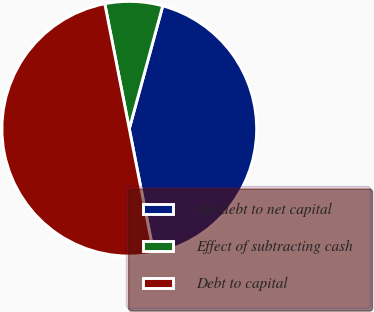Convert chart. <chart><loc_0><loc_0><loc_500><loc_500><pie_chart><fcel>Net debt to net capital<fcel>Effect of subtracting cash<fcel>Debt to capital<nl><fcel>42.69%<fcel>7.31%<fcel>50.0%<nl></chart> 